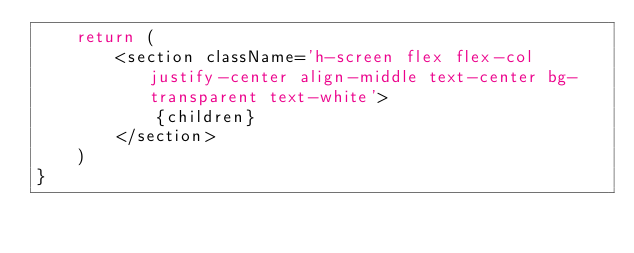<code> <loc_0><loc_0><loc_500><loc_500><_TypeScript_>	return (
		<section className='h-screen flex flex-col justify-center align-middle text-center bg-transparent text-white'>
			{children}
		</section>
	)
}
</code> 